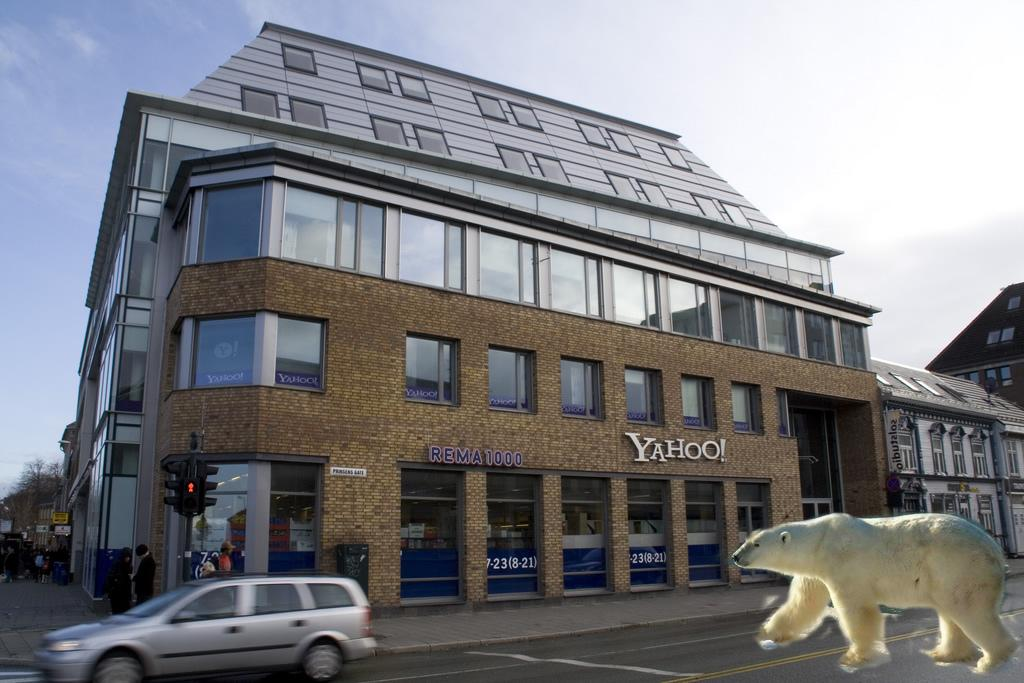What is the main structure in the middle of the image? There is a building in the middle of the image. What is happening on the left side of the image? A car is moving on the road on the left side of the image. What type of image can be seen on the right side of the image? There is an edited image of a polar bear on the right side of the image. What type of quill is the polar bear using to draw the edited image in the picture? There is no quill or drawing activity present in the image; it features an edited image of a polar bear. Who is the beginner in the image, and what are they learning? There is no indication of a beginner or any learning activity in the image. 